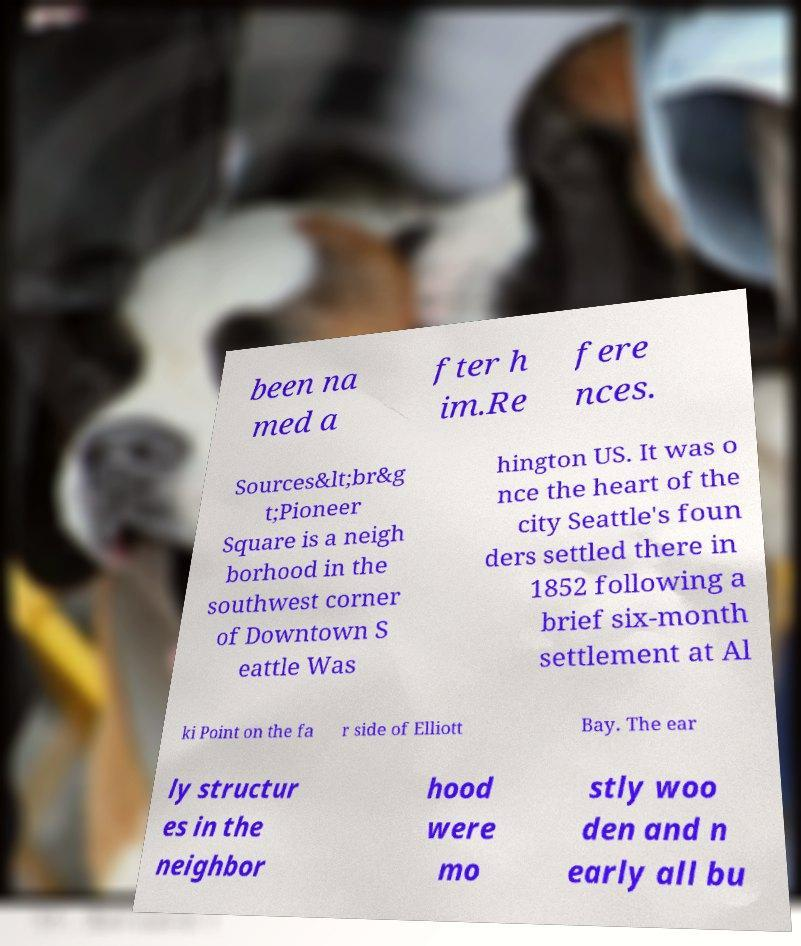Please identify and transcribe the text found in this image. been na med a fter h im.Re fere nces. Sources&lt;br&g t;Pioneer Square is a neigh borhood in the southwest corner of Downtown S eattle Was hington US. It was o nce the heart of the city Seattle's foun ders settled there in 1852 following a brief six-month settlement at Al ki Point on the fa r side of Elliott Bay. The ear ly structur es in the neighbor hood were mo stly woo den and n early all bu 